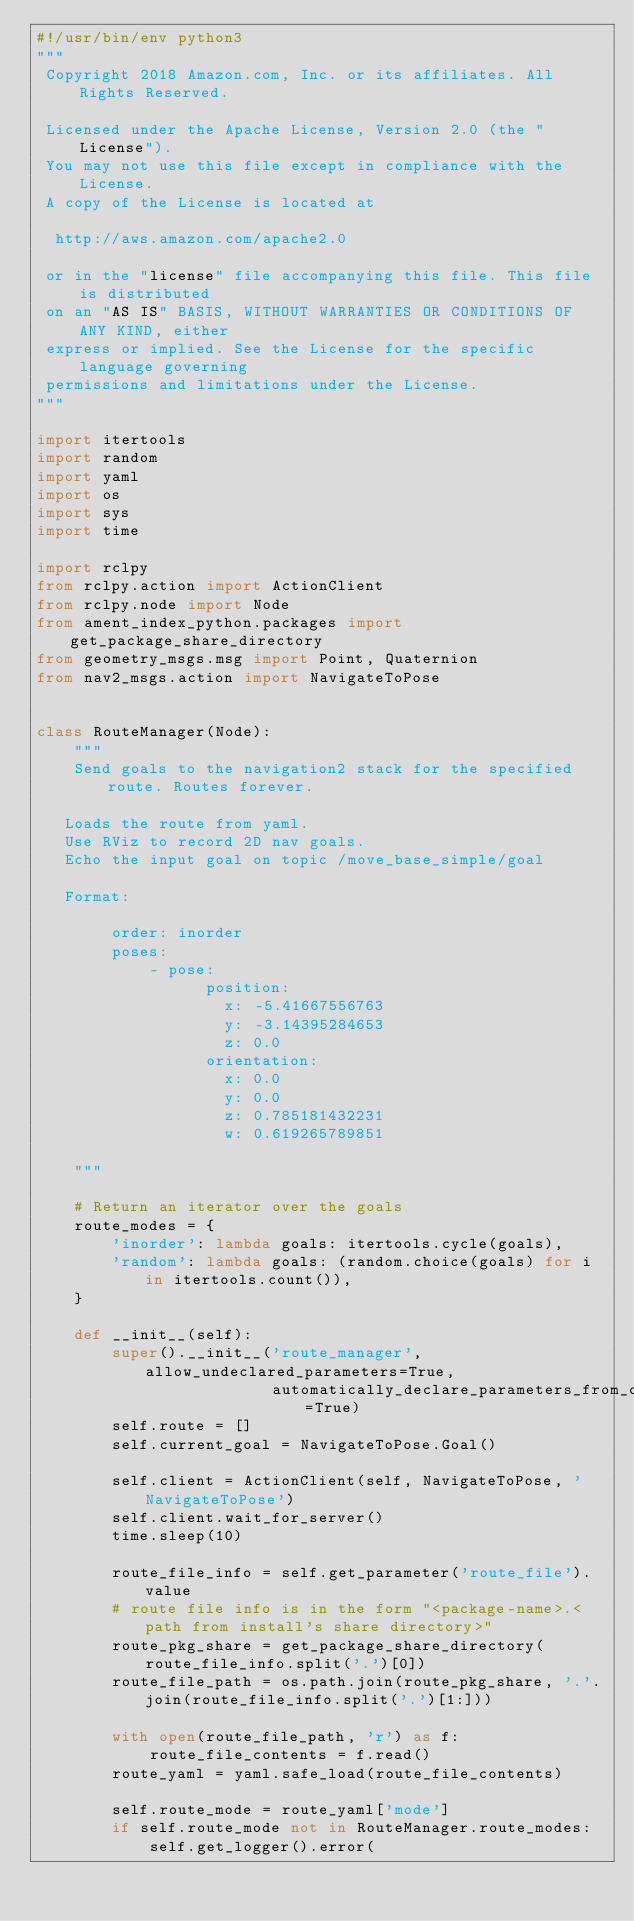Convert code to text. <code><loc_0><loc_0><loc_500><loc_500><_Python_>#!/usr/bin/env python3
"""
 Copyright 2018 Amazon.com, Inc. or its affiliates. All Rights Reserved.

 Licensed under the Apache License, Version 2.0 (the "License").
 You may not use this file except in compliance with the License.
 A copy of the License is located at

  http://aws.amazon.com/apache2.0

 or in the "license" file accompanying this file. This file is distributed
 on an "AS IS" BASIS, WITHOUT WARRANTIES OR CONDITIONS OF ANY KIND, either
 express or implied. See the License for the specific language governing
 permissions and limitations under the License.
"""

import itertools
import random
import yaml
import os
import sys
import time

import rclpy
from rclpy.action import ActionClient
from rclpy.node import Node
from ament_index_python.packages import get_package_share_directory
from geometry_msgs.msg import Point, Quaternion
from nav2_msgs.action import NavigateToPose


class RouteManager(Node):
    """
    Send goals to the navigation2 stack for the specified route. Routes forever.

   Loads the route from yaml.
   Use RViz to record 2D nav goals.
   Echo the input goal on topic /move_base_simple/goal

   Format:

        order: inorder
        poses:
            - pose:
                  position:
                    x: -5.41667556763
                    y: -3.14395284653
                    z: 0.0
                  orientation:
                    x: 0.0
                    y: 0.0
                    z: 0.785181432231
                    w: 0.619265789851

    """

    # Return an iterator over the goals
    route_modes = {
        'inorder': lambda goals: itertools.cycle(goals),
        'random': lambda goals: (random.choice(goals) for i in itertools.count()),
    }

    def __init__(self):
        super().__init__('route_manager', allow_undeclared_parameters=True,
                         automatically_declare_parameters_from_overrides=True)
        self.route = []
        self.current_goal = NavigateToPose.Goal()

        self.client = ActionClient(self, NavigateToPose, 'NavigateToPose')
        self.client.wait_for_server()
        time.sleep(10)

        route_file_info = self.get_parameter('route_file').value
        # route file info is in the form "<package-name>.<path from install's share directory>"
        route_pkg_share = get_package_share_directory(route_file_info.split('.')[0])
        route_file_path = os.path.join(route_pkg_share, '.'.join(route_file_info.split('.')[1:]))

        with open(route_file_path, 'r') as f:
            route_file_contents = f.read()
        route_yaml = yaml.safe_load(route_file_contents)

        self.route_mode = route_yaml['mode']
        if self.route_mode not in RouteManager.route_modes:
            self.get_logger().error(</code> 